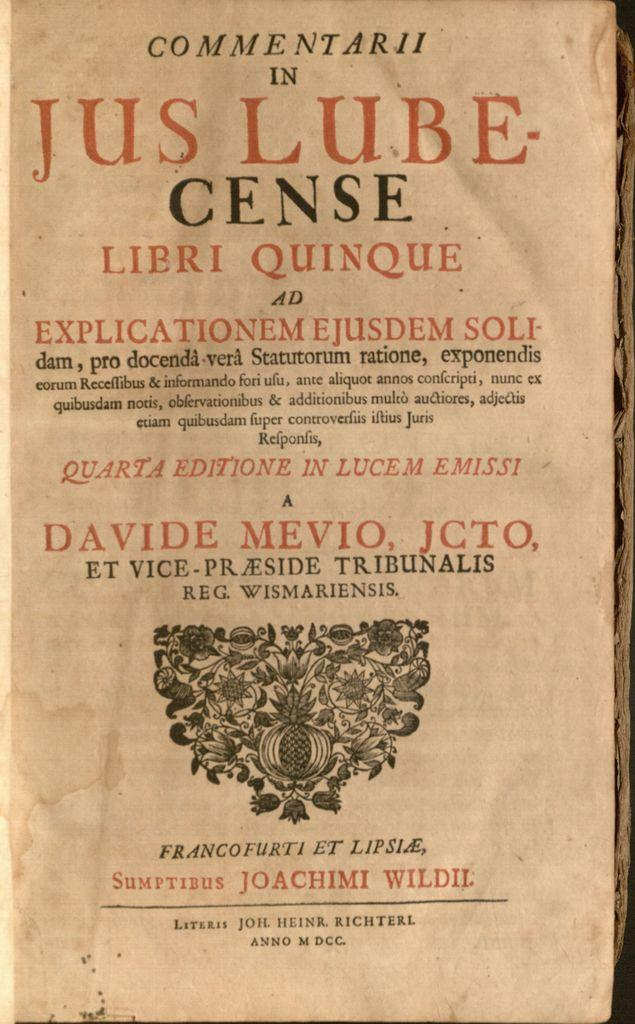Provide a one-sentence caption for the provided image. An old paper with "Commentary in Jus Lube-Cense" written at the top. 